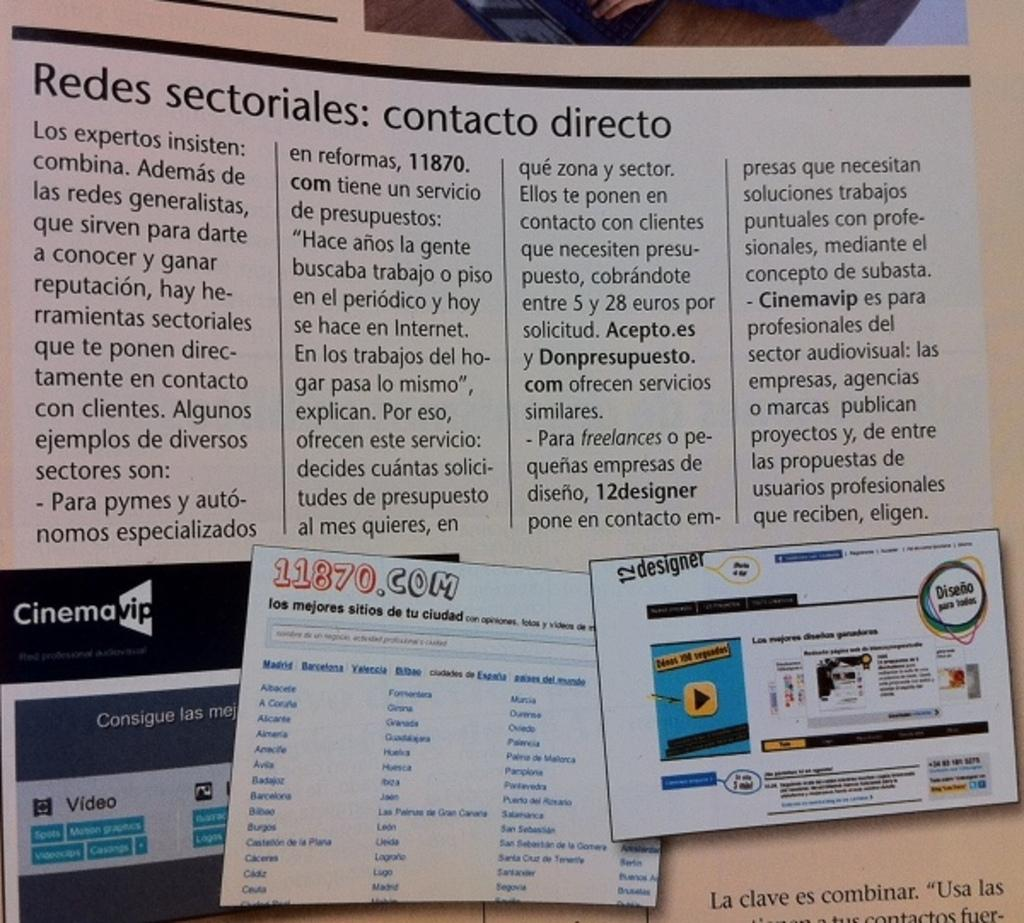<image>
Give a short and clear explanation of the subsequent image. a paper with redes written at the top 